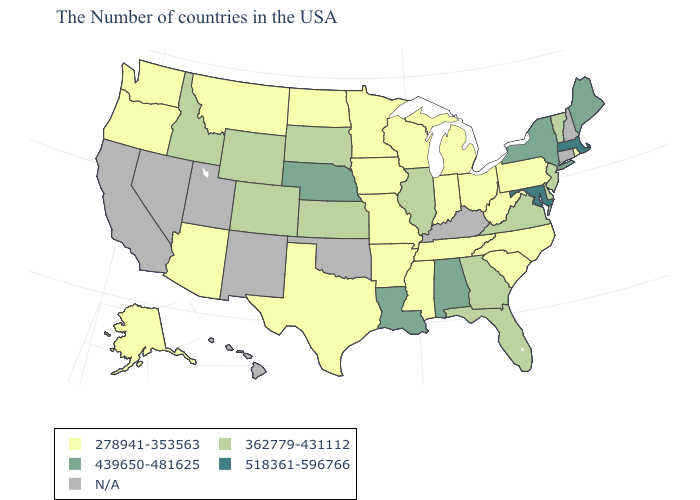How many symbols are there in the legend?
Keep it brief. 5. Is the legend a continuous bar?
Concise answer only. No. How many symbols are there in the legend?
Quick response, please. 5. What is the highest value in states that border Nevada?
Short answer required. 362779-431112. What is the value of Arkansas?
Give a very brief answer. 278941-353563. Name the states that have a value in the range N/A?
Answer briefly. New Hampshire, Connecticut, Kentucky, Oklahoma, New Mexico, Utah, Nevada, California, Hawaii. What is the value of South Dakota?
Quick response, please. 362779-431112. What is the value of Arkansas?
Keep it brief. 278941-353563. Which states have the lowest value in the USA?
Write a very short answer. Rhode Island, Pennsylvania, North Carolina, South Carolina, West Virginia, Ohio, Michigan, Indiana, Tennessee, Wisconsin, Mississippi, Missouri, Arkansas, Minnesota, Iowa, Texas, North Dakota, Montana, Arizona, Washington, Oregon, Alaska. Does Tennessee have the highest value in the South?
Answer briefly. No. Name the states that have a value in the range 278941-353563?
Write a very short answer. Rhode Island, Pennsylvania, North Carolina, South Carolina, West Virginia, Ohio, Michigan, Indiana, Tennessee, Wisconsin, Mississippi, Missouri, Arkansas, Minnesota, Iowa, Texas, North Dakota, Montana, Arizona, Washington, Oregon, Alaska. Name the states that have a value in the range 518361-596766?
Write a very short answer. Massachusetts, Maryland. Name the states that have a value in the range 362779-431112?
Be succinct. Vermont, New Jersey, Delaware, Virginia, Florida, Georgia, Illinois, Kansas, South Dakota, Wyoming, Colorado, Idaho. Which states have the highest value in the USA?
Give a very brief answer. Massachusetts, Maryland. Does Colorado have the highest value in the West?
Answer briefly. Yes. 